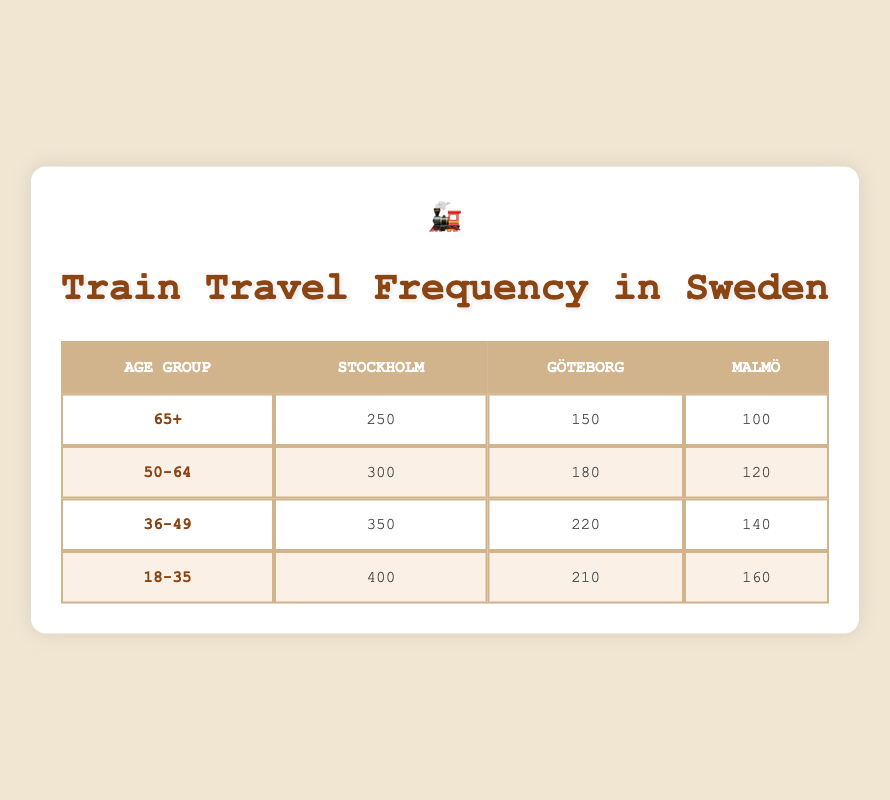What is the highest frequency of train travel among the age groups for trips to Stockholm? The table shows that the frequency of train travel to Stockholm for the age groups are: 250 for 65+, 300 for 50-64, 350 for 36-49, and 400 for 18-35. The highest frequency is therefore 400 for the age group 18-35.
Answer: 400 Which destination has the least train travel frequency for the age group 65+? The table lists the train travel frequency to the three destinations for the age group 65+: 250 to Stockholm, 150 to Göteborg, and 100 to Malmö. The least frequency is 100 for Malmö.
Answer: 100 What is the total frequency of train travel to Göteborg across all age groups? The table shows the frequencies to Göteborg by age group: 150 for 65+, 180 for 50-64, 220 for 36-49, and 210 for 18-35. We sum these values (150 + 180 + 220 + 210) which equals 760.
Answer: 760 Is it true that more people aged 50-64 travel to Malmö than those aged 65+? From the table, the frequency of travel to Malmö for age group 50-64 is 120, while for age group 65+ it is 100. Since 120 is greater than 100, the statement is true.
Answer: Yes What average frequency of train travel do people aged 36-49 have across all destinations? The frequencies for the age group 36-49 are: 350 to Stockholm, 220 to Göteborg, and 140 to Malmö. We sum these values (350 + 220 + 140) = 710, and then divide by 3 (the number of destinations), yielding an average frequency of 236.67.
Answer: 236.67 